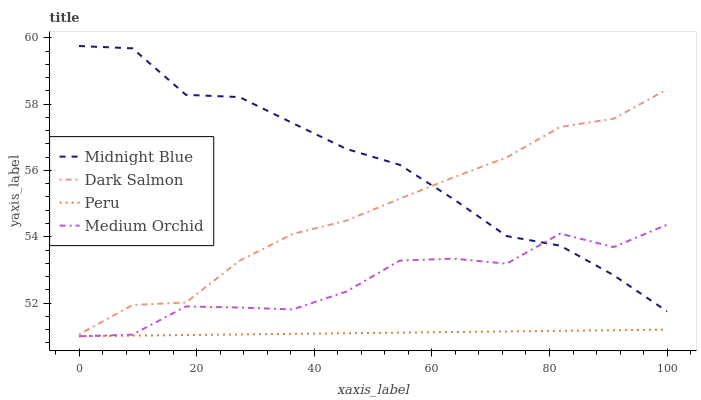Does Peru have the minimum area under the curve?
Answer yes or no. Yes. Does Midnight Blue have the maximum area under the curve?
Answer yes or no. Yes. Does Midnight Blue have the minimum area under the curve?
Answer yes or no. No. Does Peru have the maximum area under the curve?
Answer yes or no. No. Is Peru the smoothest?
Answer yes or no. Yes. Is Medium Orchid the roughest?
Answer yes or no. Yes. Is Midnight Blue the smoothest?
Answer yes or no. No. Is Midnight Blue the roughest?
Answer yes or no. No. Does Midnight Blue have the lowest value?
Answer yes or no. No. Does Peru have the highest value?
Answer yes or no. No. Is Medium Orchid less than Dark Salmon?
Answer yes or no. Yes. Is Midnight Blue greater than Peru?
Answer yes or no. Yes. Does Medium Orchid intersect Dark Salmon?
Answer yes or no. No. 